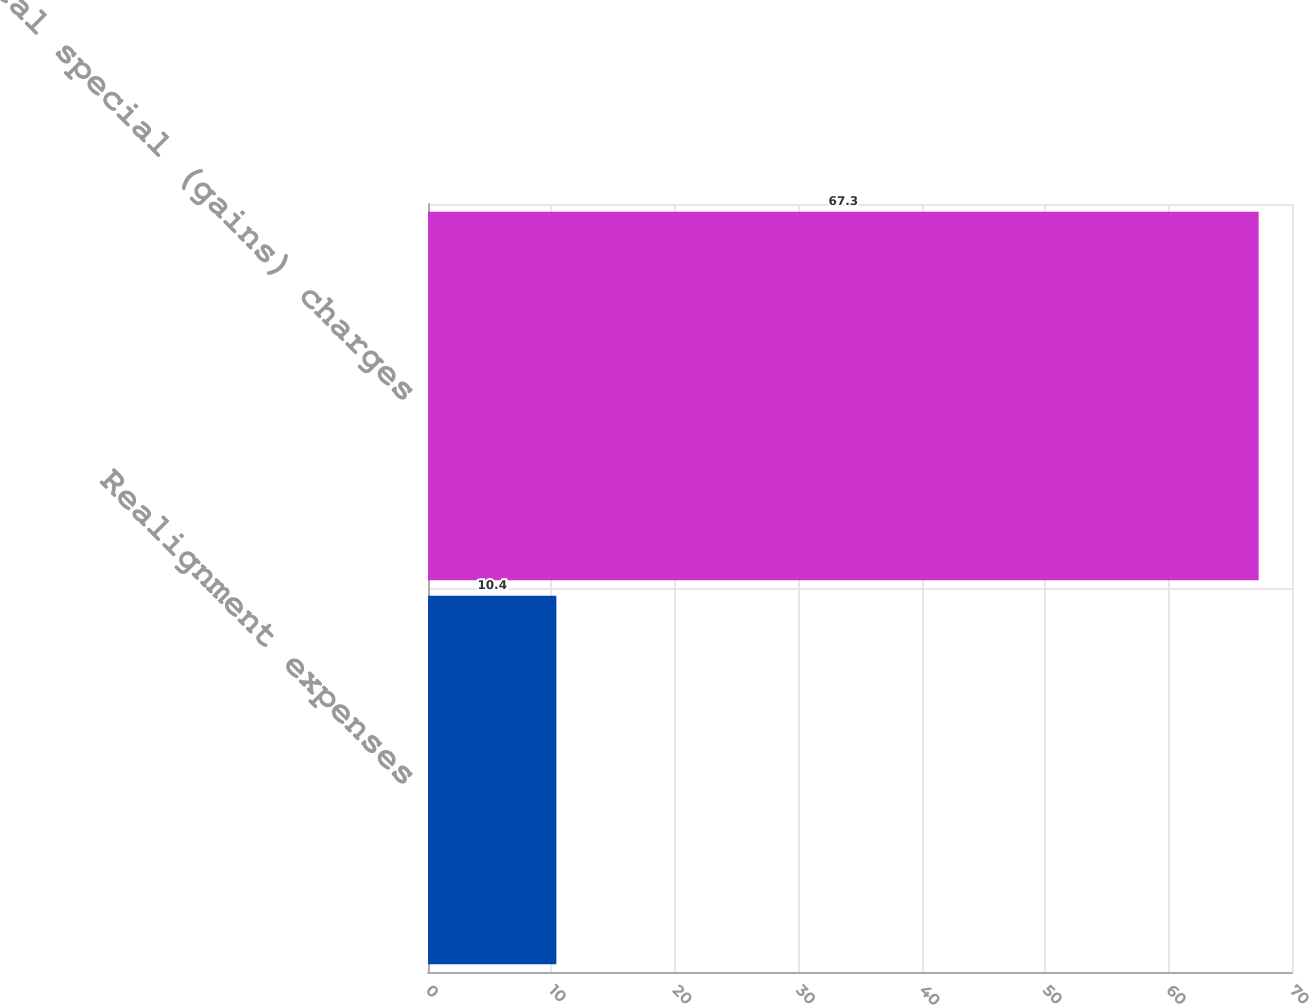<chart> <loc_0><loc_0><loc_500><loc_500><bar_chart><fcel>Realignment expenses<fcel>Total special (gains) charges<nl><fcel>10.4<fcel>67.3<nl></chart> 